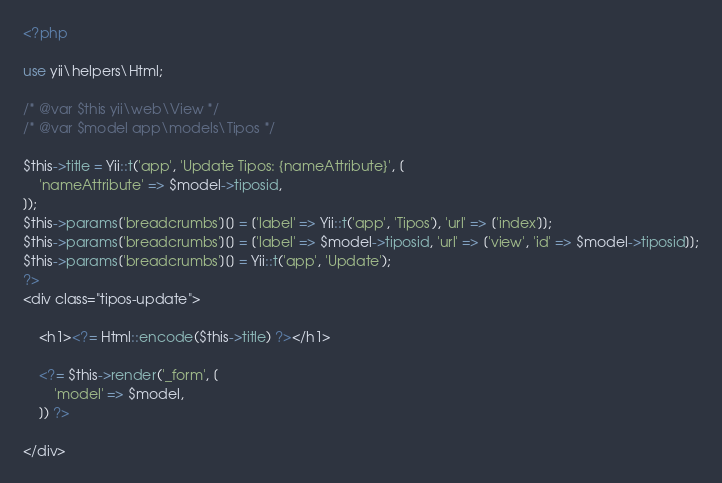<code> <loc_0><loc_0><loc_500><loc_500><_PHP_><?php

use yii\helpers\Html;

/* @var $this yii\web\View */
/* @var $model app\models\Tipos */

$this->title = Yii::t('app', 'Update Tipos: {nameAttribute}', [
    'nameAttribute' => $model->tiposid,
]);
$this->params['breadcrumbs'][] = ['label' => Yii::t('app', 'Tipos'), 'url' => ['index']];
$this->params['breadcrumbs'][] = ['label' => $model->tiposid, 'url' => ['view', 'id' => $model->tiposid]];
$this->params['breadcrumbs'][] = Yii::t('app', 'Update');
?>
<div class="tipos-update">

    <h1><?= Html::encode($this->title) ?></h1>

    <?= $this->render('_form', [
        'model' => $model,
    ]) ?>

</div>
</code> 